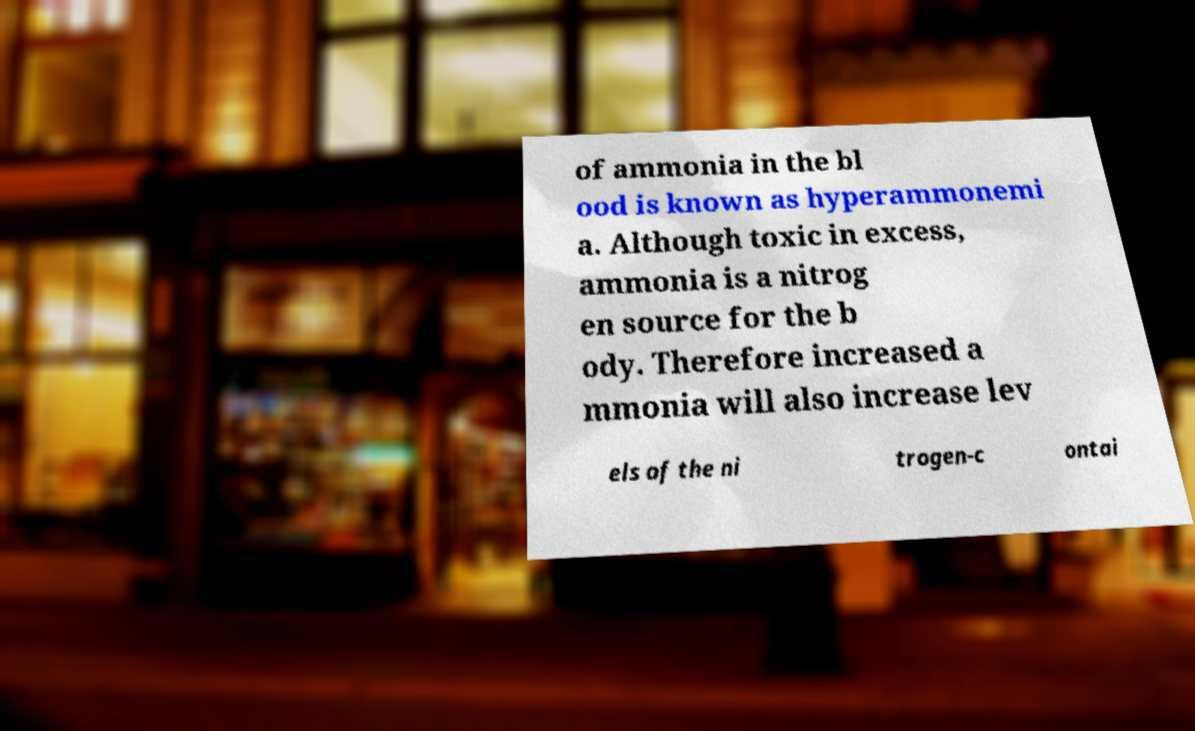Could you assist in decoding the text presented in this image and type it out clearly? of ammonia in the bl ood is known as hyperammonemi a. Although toxic in excess, ammonia is a nitrog en source for the b ody. Therefore increased a mmonia will also increase lev els of the ni trogen-c ontai 